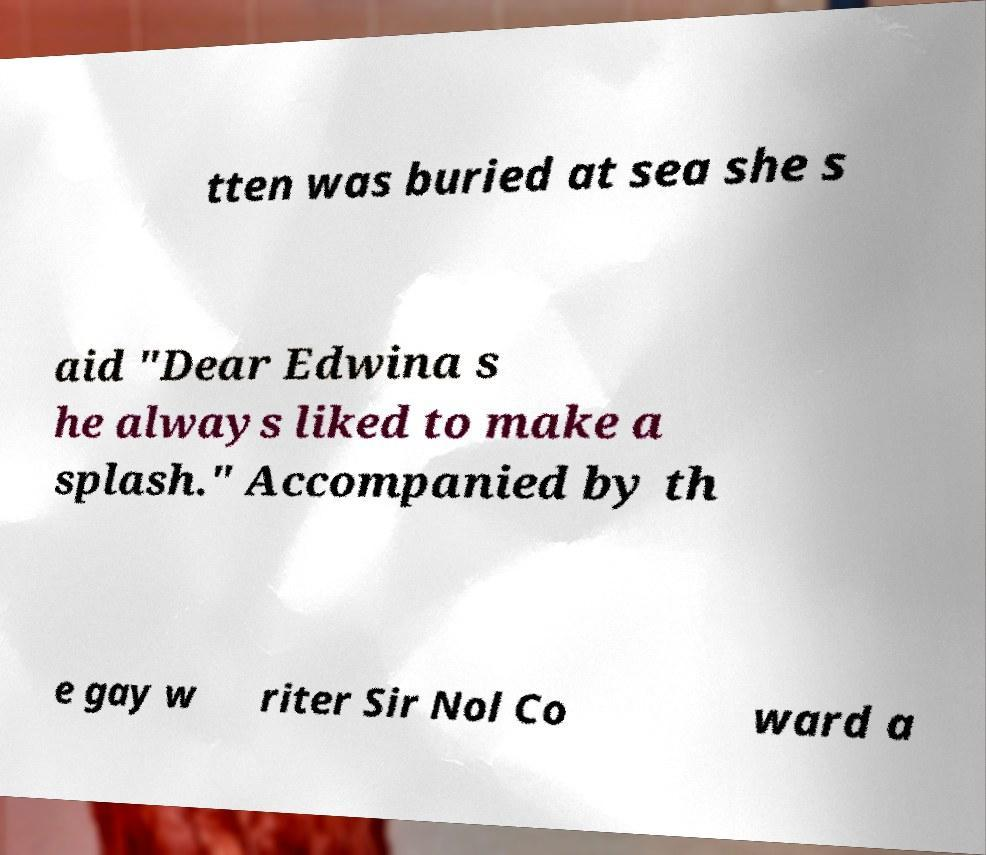Could you assist in decoding the text presented in this image and type it out clearly? tten was buried at sea she s aid "Dear Edwina s he always liked to make a splash." Accompanied by th e gay w riter Sir Nol Co ward a 